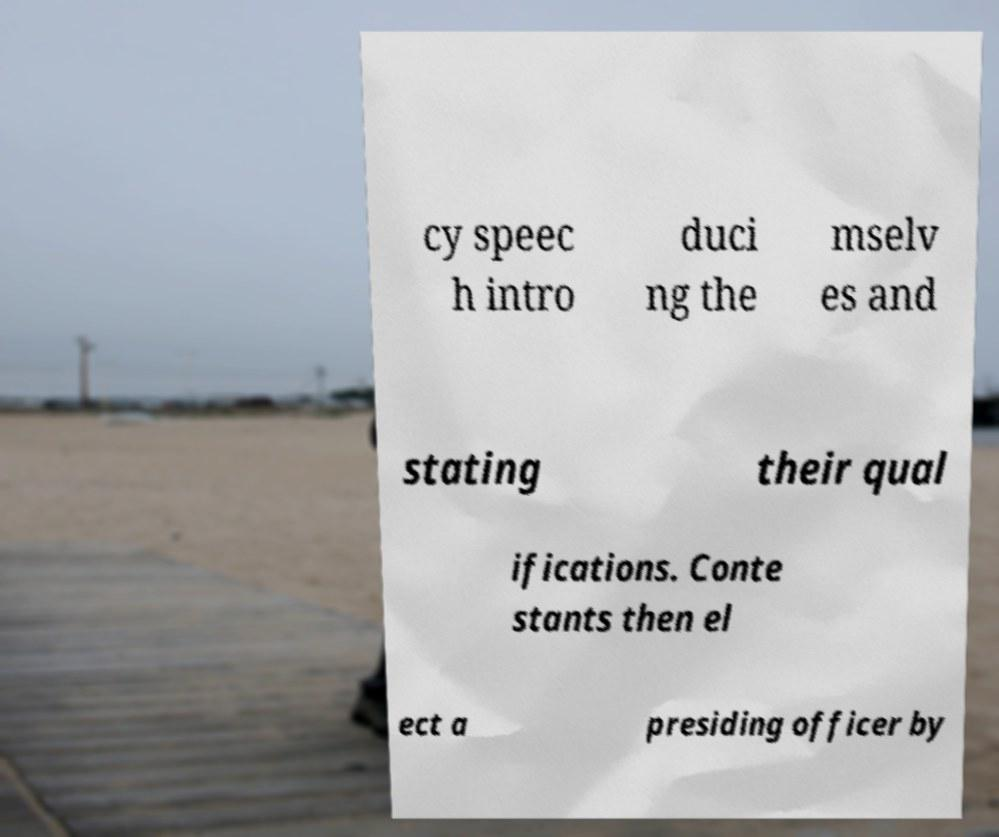I need the written content from this picture converted into text. Can you do that? cy speec h intro duci ng the mselv es and stating their qual ifications. Conte stants then el ect a presiding officer by 